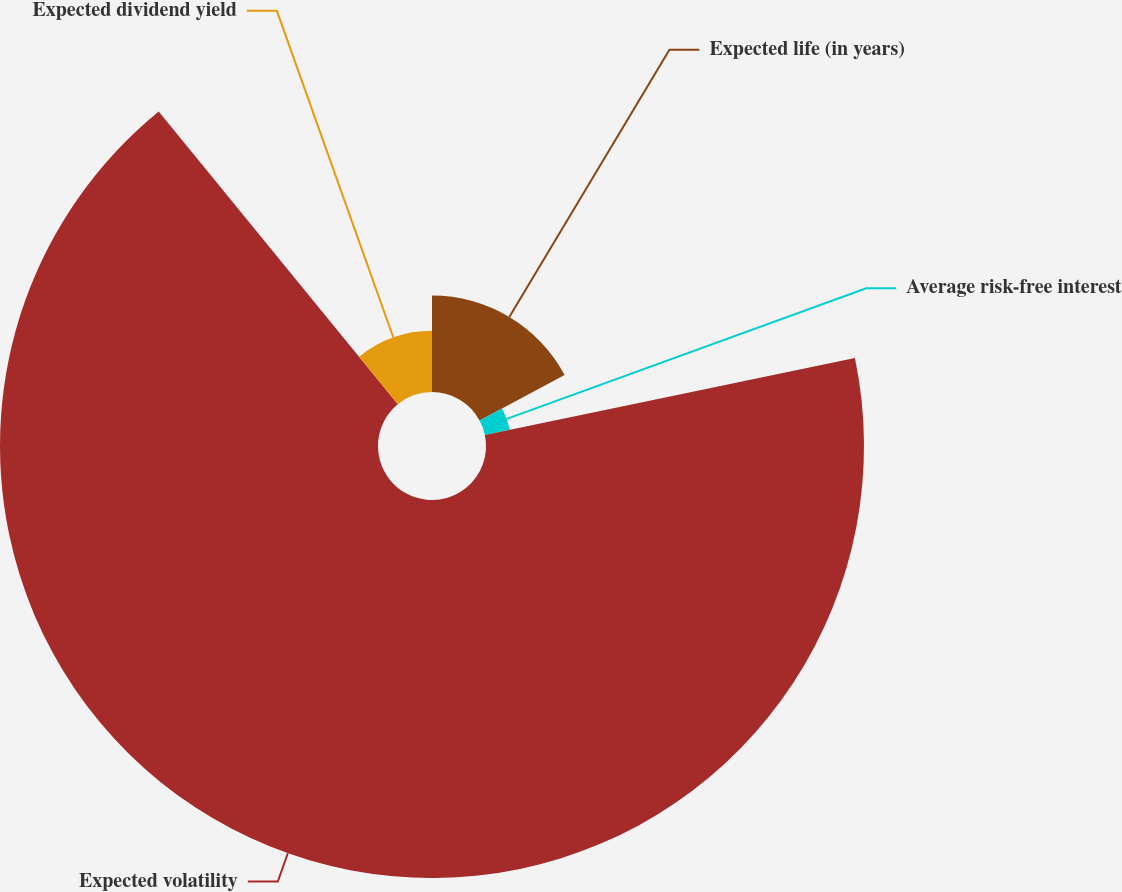Convert chart to OTSL. <chart><loc_0><loc_0><loc_500><loc_500><pie_chart><fcel>Expected life (in years)<fcel>Average risk-free interest<fcel>Expected volatility<fcel>Expected dividend yield<nl><fcel>17.18%<fcel>4.55%<fcel>67.36%<fcel>10.9%<nl></chart> 